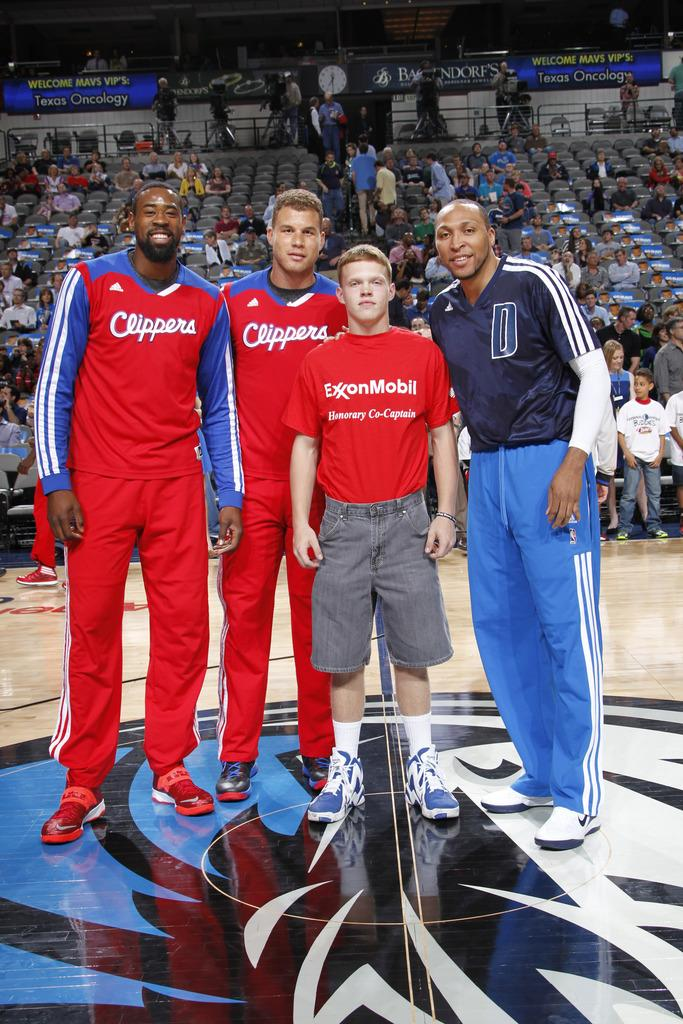<image>
Summarize the visual content of the image. four men stand on the court one has a tshirt that says Exxon Mobile  two are players for the clippers. 